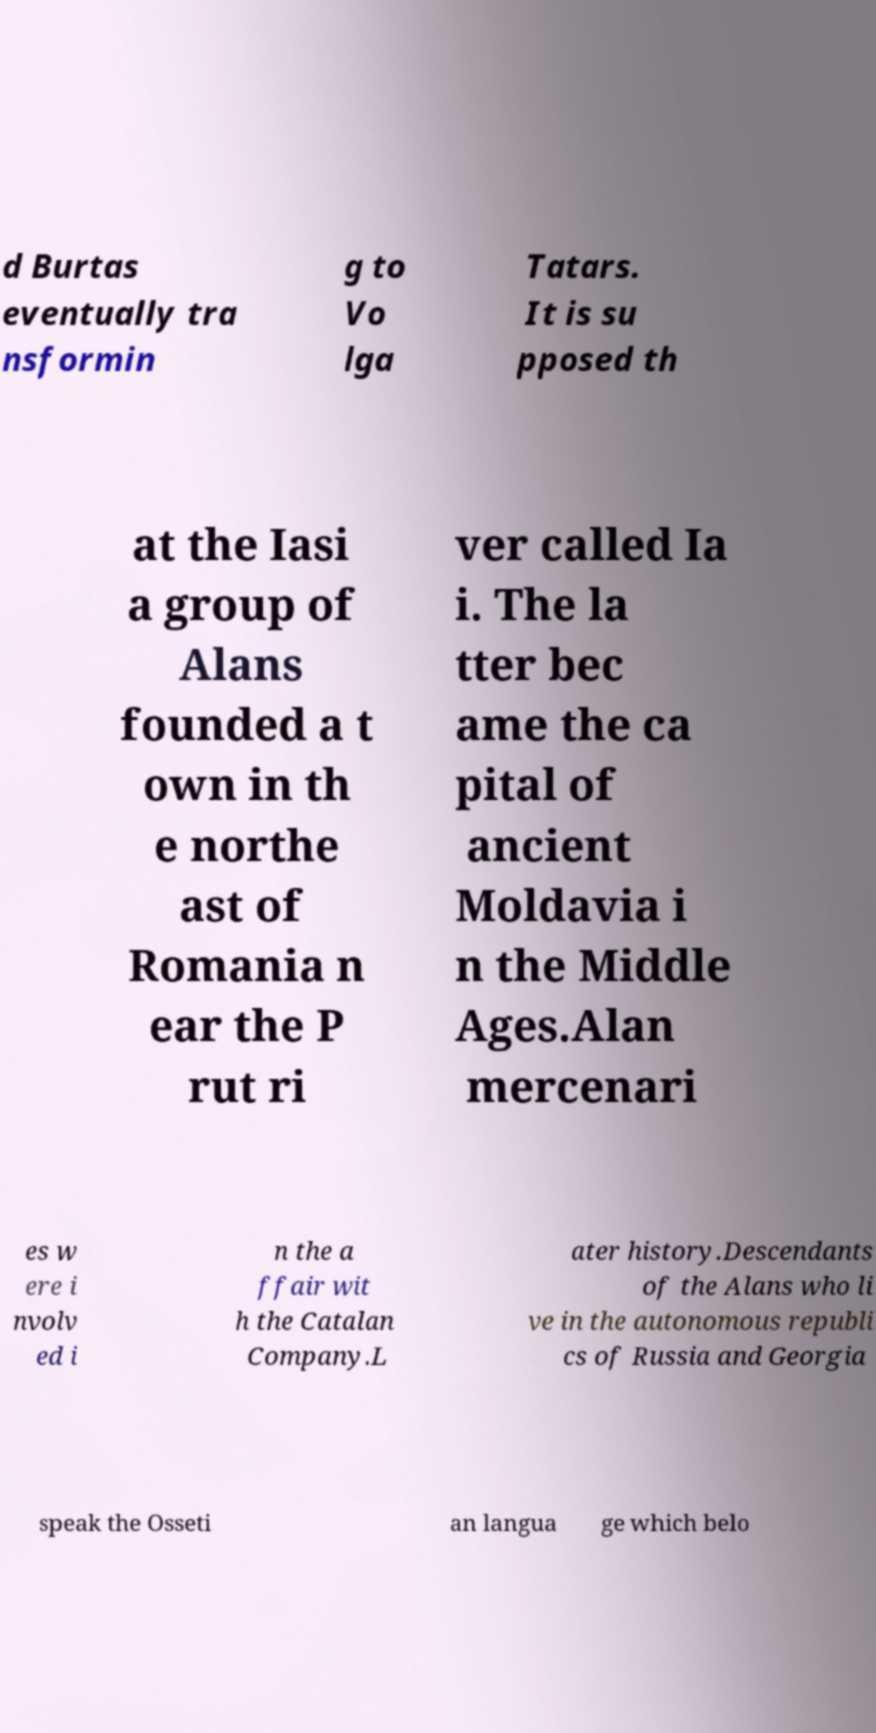Please identify and transcribe the text found in this image. d Burtas eventually tra nsformin g to Vo lga Tatars. It is su pposed th at the Iasi a group of Alans founded a t own in th e northe ast of Romania n ear the P rut ri ver called Ia i. The la tter bec ame the ca pital of ancient Moldavia i n the Middle Ages.Alan mercenari es w ere i nvolv ed i n the a ffair wit h the Catalan Company.L ater history.Descendants of the Alans who li ve in the autonomous republi cs of Russia and Georgia speak the Osseti an langua ge which belo 